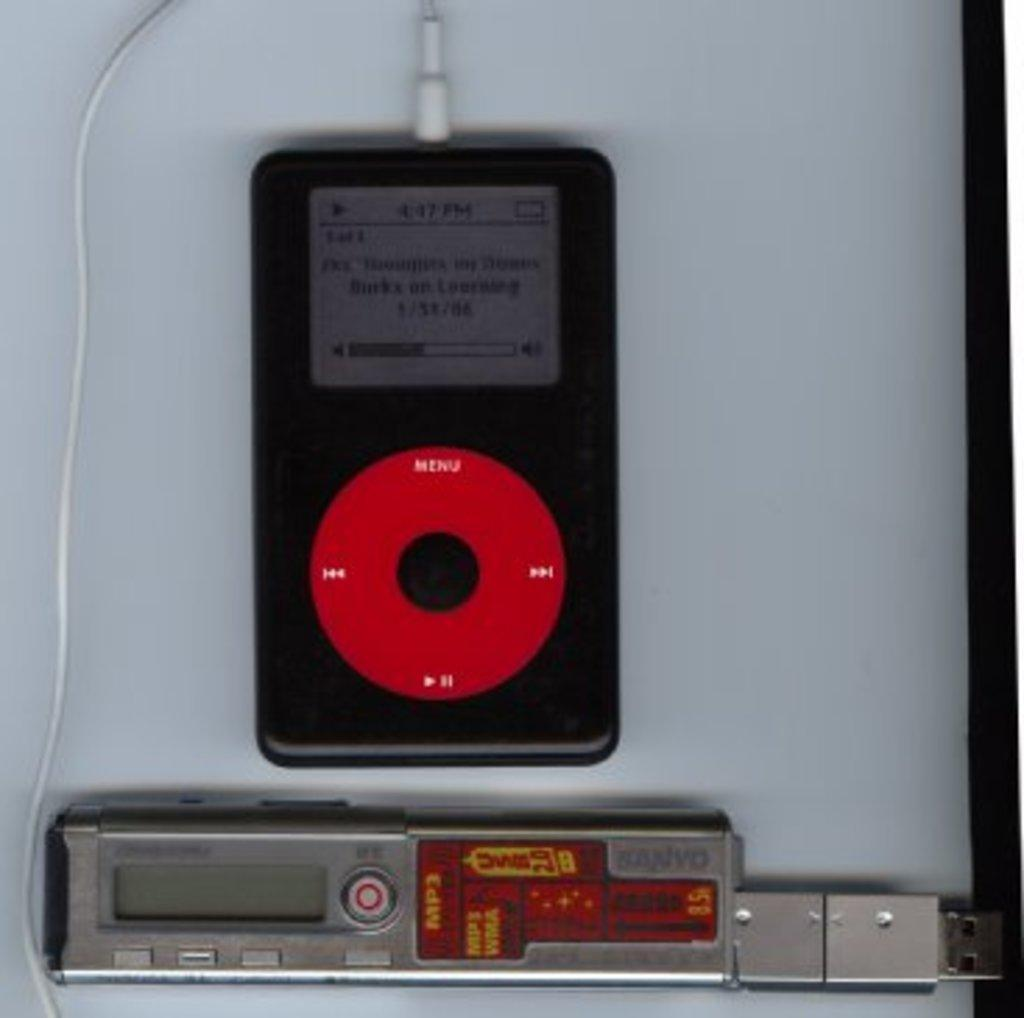What type of electronic device is visible in the image? There is an electronic gadget in the image. Can you describe the connection of the electronic gadget? The electronic gadget has a wire plugged in. What else can be seen on the floor in the image? There is another item on the floor in the image. What type of food is being organized on the floor in the image? There is no food present in the image, and the image does not depict any organization activities. 